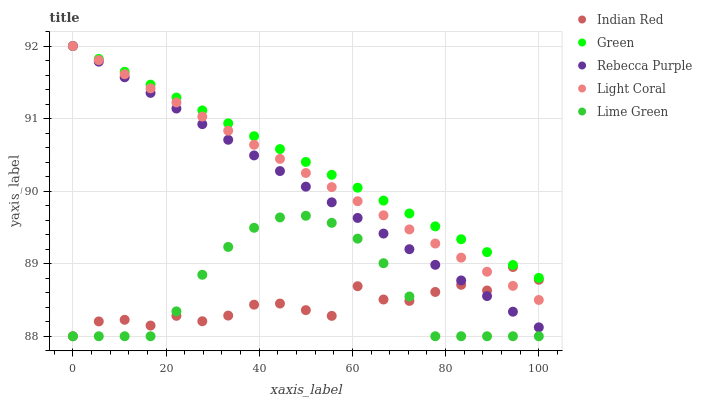Does Indian Red have the minimum area under the curve?
Answer yes or no. Yes. Does Green have the maximum area under the curve?
Answer yes or no. Yes. Does Lime Green have the minimum area under the curve?
Answer yes or no. No. Does Lime Green have the maximum area under the curve?
Answer yes or no. No. Is Rebecca Purple the smoothest?
Answer yes or no. Yes. Is Indian Red the roughest?
Answer yes or no. Yes. Is Lime Green the smoothest?
Answer yes or no. No. Is Lime Green the roughest?
Answer yes or no. No. Does Lime Green have the lowest value?
Answer yes or no. Yes. Does Green have the lowest value?
Answer yes or no. No. Does Rebecca Purple have the highest value?
Answer yes or no. Yes. Does Lime Green have the highest value?
Answer yes or no. No. Is Indian Red less than Green?
Answer yes or no. Yes. Is Green greater than Lime Green?
Answer yes or no. Yes. Does Indian Red intersect Light Coral?
Answer yes or no. Yes. Is Indian Red less than Light Coral?
Answer yes or no. No. Is Indian Red greater than Light Coral?
Answer yes or no. No. Does Indian Red intersect Green?
Answer yes or no. No. 